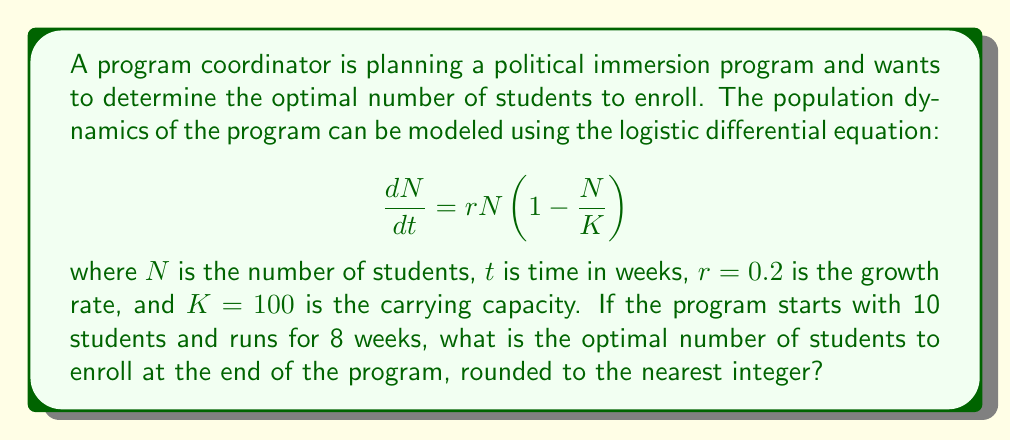Can you answer this question? To solve this problem, we need to follow these steps:

1) The logistic differential equation given is:

   $$\frac{dN}{dt} = rN\left(1 - \frac{N}{K}\right)$$

2) The solution to this equation is:

   $$N(t) = \frac{K}{1 + \left(\frac{K}{N_0} - 1\right)e^{-rt}}$$

   where $N_0$ is the initial population.

3) We are given:
   - $r = 0.2$ (growth rate)
   - $K = 100$ (carrying capacity)
   - $N_0 = 10$ (initial number of students)
   - $t = 8$ (time in weeks)

4) Let's substitute these values into our solution:

   $$N(8) = \frac{100}{1 + \left(\frac{100}{10} - 1\right)e^{-0.2 \cdot 8}}$$

5) Simplify:
   $$N(8) = \frac{100}{1 + 9e^{-1.6}}$$

6) Calculate:
   $$N(8) \approx 71.38$$

7) Rounding to the nearest integer:
   $$N(8) \approx 71$$

Therefore, the optimal number of students to enroll at the end of the 8-week program is 71.
Answer: 71 students 